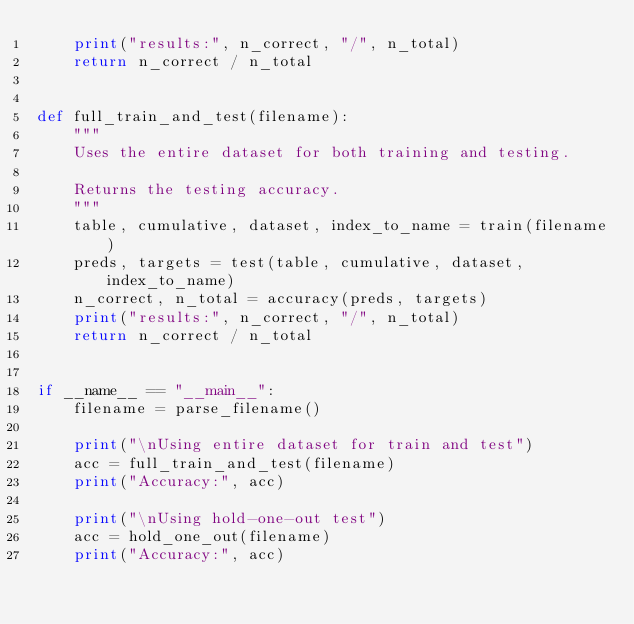Convert code to text. <code><loc_0><loc_0><loc_500><loc_500><_Python_>    print("results:", n_correct, "/", n_total)
    return n_correct / n_total


def full_train_and_test(filename):
    """
    Uses the entire dataset for both training and testing.

    Returns the testing accuracy.
    """
    table, cumulative, dataset, index_to_name = train(filename)
    preds, targets = test(table, cumulative, dataset, index_to_name)
    n_correct, n_total = accuracy(preds, targets)
    print("results:", n_correct, "/", n_total)
    return n_correct / n_total


if __name__ == "__main__":
    filename = parse_filename()

    print("\nUsing entire dataset for train and test")
    acc = full_train_and_test(filename)
    print("Accuracy:", acc)

    print("\nUsing hold-one-out test")
    acc = hold_one_out(filename)
    print("Accuracy:", acc)
</code> 